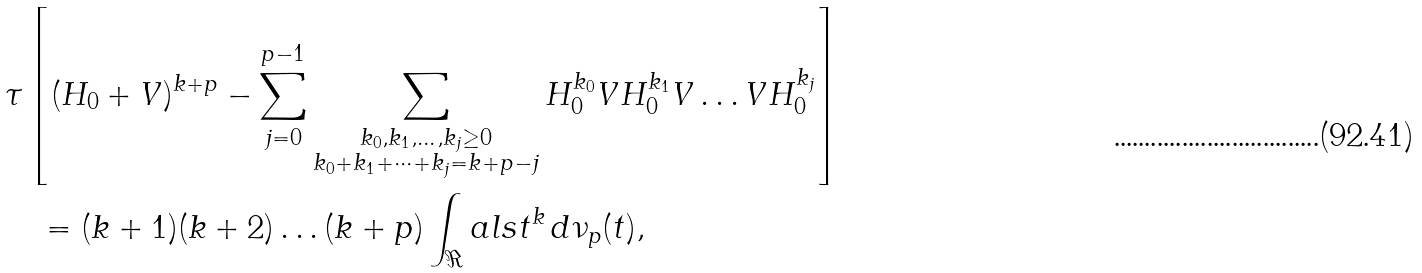<formula> <loc_0><loc_0><loc_500><loc_500>& \tau \left [ ( H _ { 0 } + V ) ^ { k + p } - \sum _ { j = 0 } ^ { p - 1 } \sum _ { \substack { k _ { 0 } , k _ { 1 } , \dots , k _ { j } \geq 0 \\ k _ { 0 } + k _ { 1 } + \dots + k _ { j } = k + p - j } } H _ { 0 } ^ { k _ { 0 } } V H _ { 0 } ^ { k _ { 1 } } V \dots V H _ { 0 } ^ { k _ { j } } \right ] \\ & \quad = ( k + 1 ) ( k + 2 ) \dots ( k + p ) \int _ { \Re } a l s t ^ { k } \, d \nu _ { p } ( t ) ,</formula> 